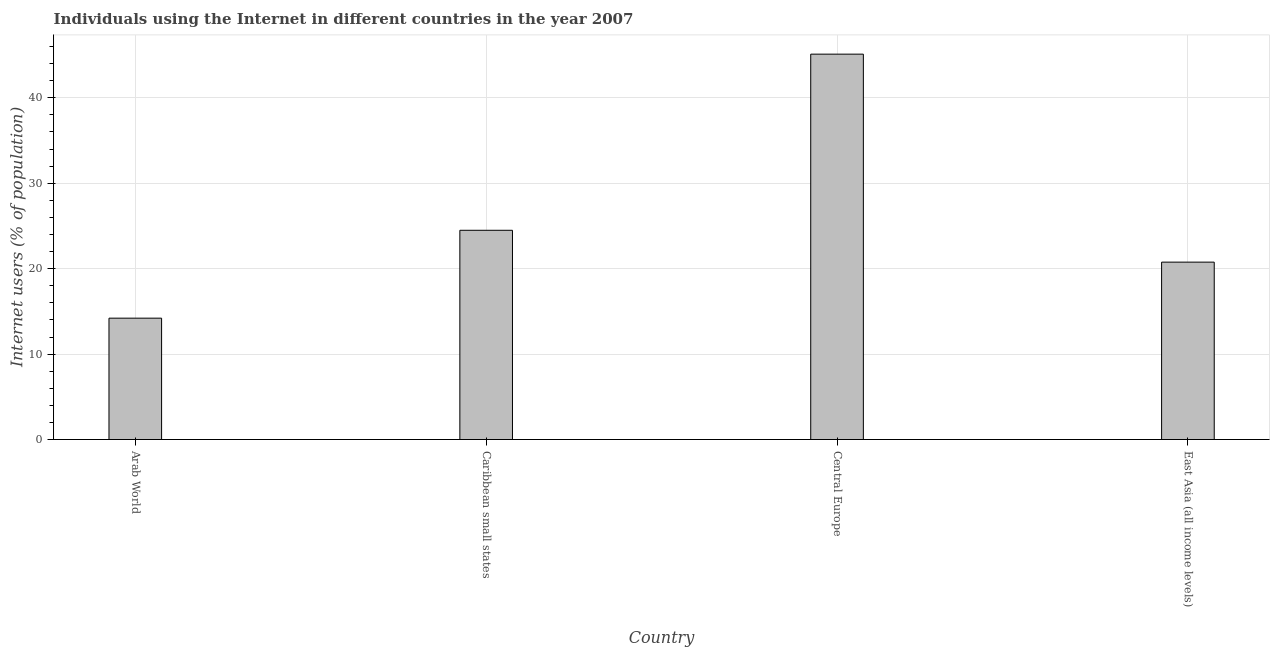What is the title of the graph?
Your response must be concise. Individuals using the Internet in different countries in the year 2007. What is the label or title of the Y-axis?
Keep it short and to the point. Internet users (% of population). What is the number of internet users in Central Europe?
Offer a terse response. 45.11. Across all countries, what is the maximum number of internet users?
Your response must be concise. 45.11. Across all countries, what is the minimum number of internet users?
Offer a terse response. 14.21. In which country was the number of internet users maximum?
Provide a succinct answer. Central Europe. In which country was the number of internet users minimum?
Your response must be concise. Arab World. What is the sum of the number of internet users?
Your response must be concise. 104.58. What is the difference between the number of internet users in Arab World and Caribbean small states?
Make the answer very short. -10.29. What is the average number of internet users per country?
Your response must be concise. 26.14. What is the median number of internet users?
Offer a terse response. 22.63. What is the ratio of the number of internet users in Caribbean small states to that in Central Europe?
Your response must be concise. 0.54. Is the number of internet users in Arab World less than that in Central Europe?
Provide a succinct answer. Yes. What is the difference between the highest and the second highest number of internet users?
Provide a succinct answer. 20.62. Is the sum of the number of internet users in Caribbean small states and Central Europe greater than the maximum number of internet users across all countries?
Your answer should be very brief. Yes. What is the difference between the highest and the lowest number of internet users?
Give a very brief answer. 30.91. What is the difference between two consecutive major ticks on the Y-axis?
Your response must be concise. 10. Are the values on the major ticks of Y-axis written in scientific E-notation?
Ensure brevity in your answer.  No. What is the Internet users (% of population) of Arab World?
Your answer should be very brief. 14.21. What is the Internet users (% of population) in Caribbean small states?
Provide a succinct answer. 24.49. What is the Internet users (% of population) in Central Europe?
Offer a very short reply. 45.11. What is the Internet users (% of population) of East Asia (all income levels)?
Make the answer very short. 20.77. What is the difference between the Internet users (% of population) in Arab World and Caribbean small states?
Provide a succinct answer. -10.29. What is the difference between the Internet users (% of population) in Arab World and Central Europe?
Provide a short and direct response. -30.91. What is the difference between the Internet users (% of population) in Arab World and East Asia (all income levels)?
Provide a short and direct response. -6.56. What is the difference between the Internet users (% of population) in Caribbean small states and Central Europe?
Make the answer very short. -20.62. What is the difference between the Internet users (% of population) in Caribbean small states and East Asia (all income levels)?
Make the answer very short. 3.73. What is the difference between the Internet users (% of population) in Central Europe and East Asia (all income levels)?
Your answer should be compact. 24.35. What is the ratio of the Internet users (% of population) in Arab World to that in Caribbean small states?
Your response must be concise. 0.58. What is the ratio of the Internet users (% of population) in Arab World to that in Central Europe?
Your response must be concise. 0.32. What is the ratio of the Internet users (% of population) in Arab World to that in East Asia (all income levels)?
Ensure brevity in your answer.  0.68. What is the ratio of the Internet users (% of population) in Caribbean small states to that in Central Europe?
Ensure brevity in your answer.  0.54. What is the ratio of the Internet users (% of population) in Caribbean small states to that in East Asia (all income levels)?
Keep it short and to the point. 1.18. What is the ratio of the Internet users (% of population) in Central Europe to that in East Asia (all income levels)?
Your answer should be very brief. 2.17. 